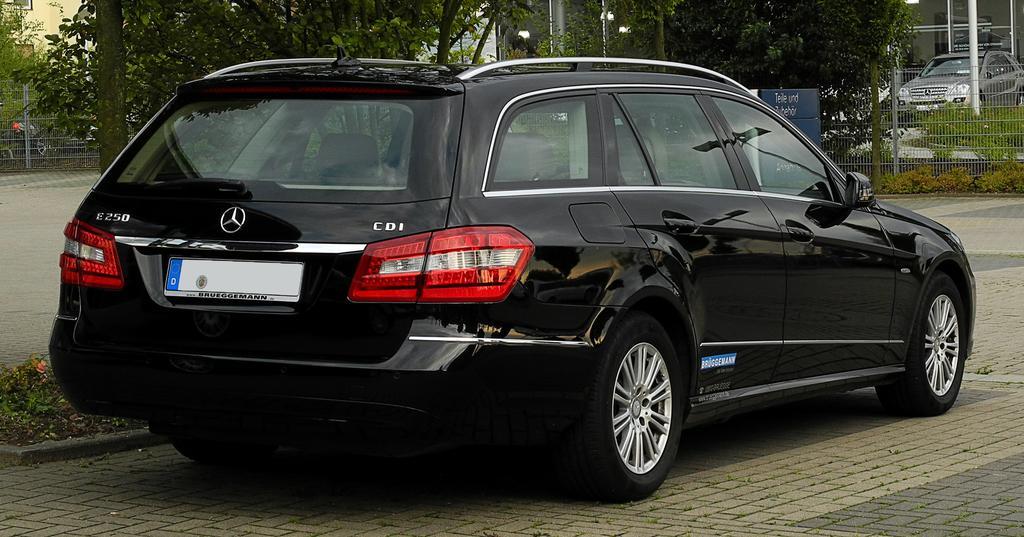How would you summarize this image in a sentence or two? In the center of the image we can see a car which is in black color. In the background there are trees, fence, poles and a car. 